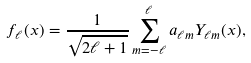Convert formula to latex. <formula><loc_0><loc_0><loc_500><loc_500>f _ { \ell } ( x ) = \frac { 1 } { \sqrt { 2 \ell + 1 } } \sum _ { m = - \ell } ^ { \ell } a _ { \ell m } Y _ { \ell m } ( x ) ,</formula> 